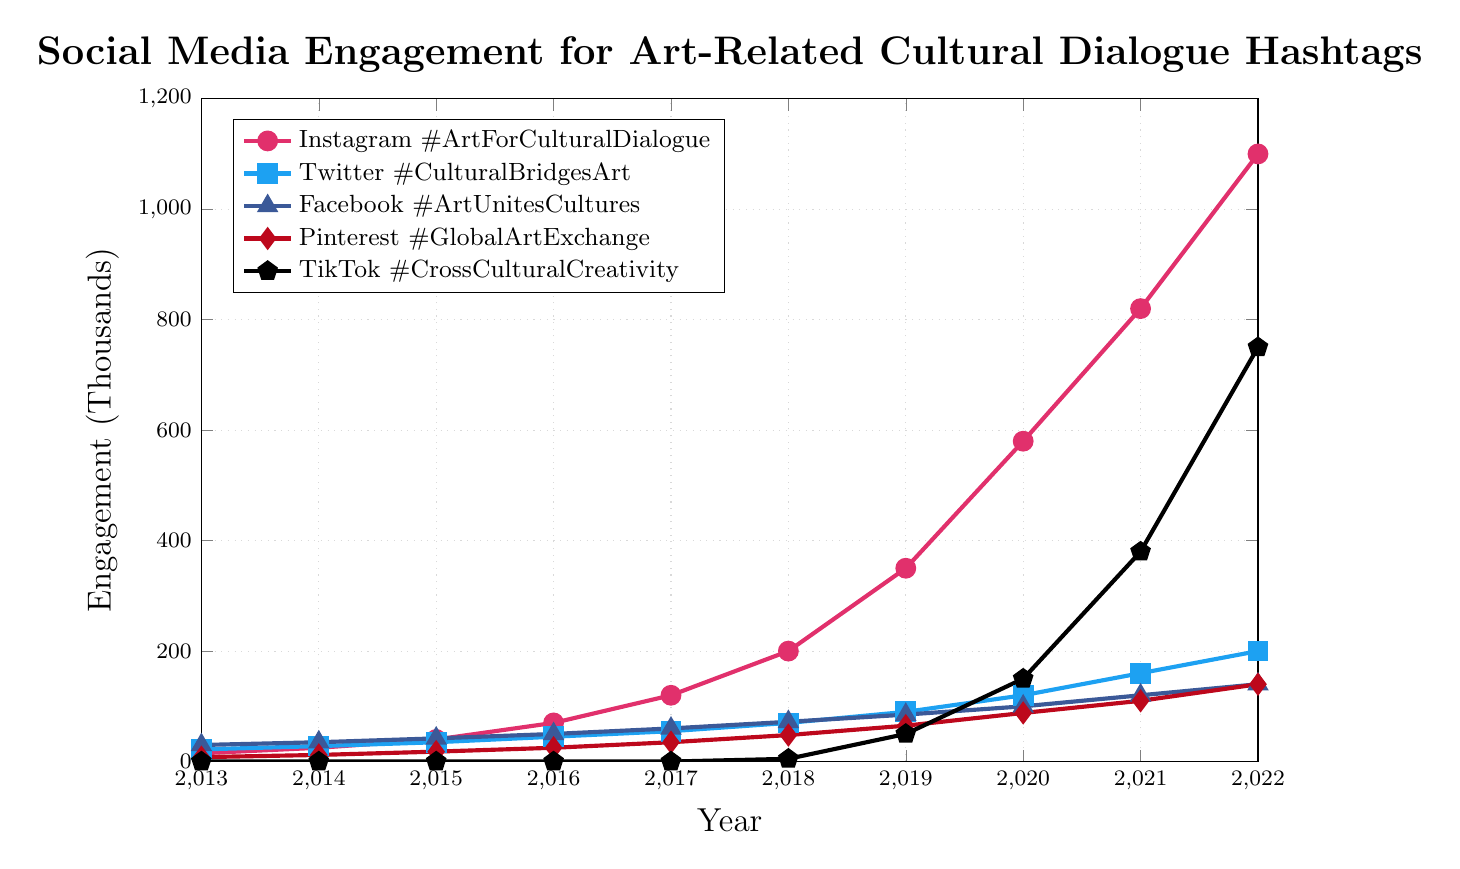Which platform had the highest engagement in 2022? Looking at the figure for the year 2022, the line that is highest on the y-axis represents the platform with the highest engagement. TikTok's line is highest, surpassing the others.
Answer: TikTok How did Instagram engagement change from 2013 to 2022? The Instagram line starts at 15 (thousand) in 2013 and ends at 1100 (thousand) in 2022. Thus, it went from 15 thousand to 1100 thousand over these years.
Answer: Increased What was the total engagement for Facebook across the decade? Sum the Facebook engagement values for each year from 2013 to 2022: 30+35+42+50+60+72+85+100+120+140.
Answer: 734 thousand Which platforms reached an engagement of at least 100 thousand by 2020? By looking at the y-axis values in the year 2020, Instagram, Twitter, Facebook, and TikTok each show 100 thousand or more. Pinterest is below this mark.
Answer: Instagram, Twitter, Facebook, TikTok Compare the engagement growth of Instagram and Twitter from 2018 to 2022. Which platform grew more? Calculate the increment for Instagram: 1100 - 200 = 900 (thousand). For Twitter: 200 - 70 = 130 (thousand). Instagram had a larger increase.
Answer: Instagram What was Pinterest's engagement in 2016 compared to TikTok's engagement that year? In 2016, Pinterest had an engagement of 25 thousand, whereas TikTok had 0, since TikTok engagement started in 2018.
Answer: Pinterest What is the average engagement for Twitter from 2019 to 2022? Add Twitter's engagement values from these years and divide by 4: (90 + 120 + 160 + 200) / 4 = 142.5.
Answer: 142.5 thousand In which year did TikTok see the most significant increase in engagement? By looking at the slopes of the TikTok line, one can see the steepest rise between 2021 (380) and 2022 (750). The increment is 750 - 380 = 370 (thousand).
Answer: 2022 Which platform had lower engagement in 2018 compared to Instagram's engagement in 2014? Instagram's engagement in 2014 is 25 thousand. In 2018, all platforms except TikTok had more than 25 thousand engagements. TikTok had 5 thousand.
Answer: TikTok How does the engagement trend of Pinterest compare visually to that of Facebook from 2013 to 2022? Both lines have an upward trend, but Pinterest's slope is less steep compared to Facebook. Pinterest's increase is more gradual over the years compared to the sharper rise in Facebook's engagement.
Answer: Facebook rose more steeply 